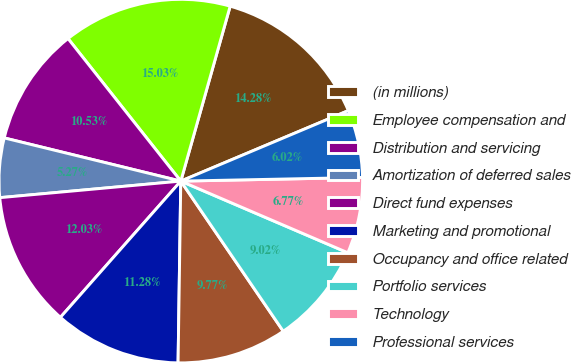Convert chart. <chart><loc_0><loc_0><loc_500><loc_500><pie_chart><fcel>(in millions)<fcel>Employee compensation and<fcel>Distribution and servicing<fcel>Amortization of deferred sales<fcel>Direct fund expenses<fcel>Marketing and promotional<fcel>Occupancy and office related<fcel>Portfolio services<fcel>Technology<fcel>Professional services<nl><fcel>14.28%<fcel>15.03%<fcel>10.53%<fcel>5.27%<fcel>12.03%<fcel>11.28%<fcel>9.77%<fcel>9.02%<fcel>6.77%<fcel>6.02%<nl></chart> 